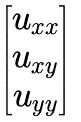Convert formula to latex. <formula><loc_0><loc_0><loc_500><loc_500>\begin{bmatrix} u _ { x x } \\ u _ { x y } \\ u _ { y y } \end{bmatrix}</formula> 